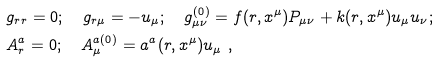Convert formula to latex. <formula><loc_0><loc_0><loc_500><loc_500>& g _ { r r } = 0 ; \quad g _ { r \mu } = - u _ { \mu } ; \quad g ^ { ( 0 ) } _ { \mu \nu } = f ( r , x ^ { \mu } ) P _ { \mu \nu } + k ( r , x ^ { \mu } ) u _ { \mu } u _ { \nu } ; \\ & A ^ { a } _ { r } = 0 ; \quad A ^ { a ( 0 ) } _ { \mu } = a ^ { a } ( r , x ^ { \mu } ) u _ { \mu } \ ,</formula> 